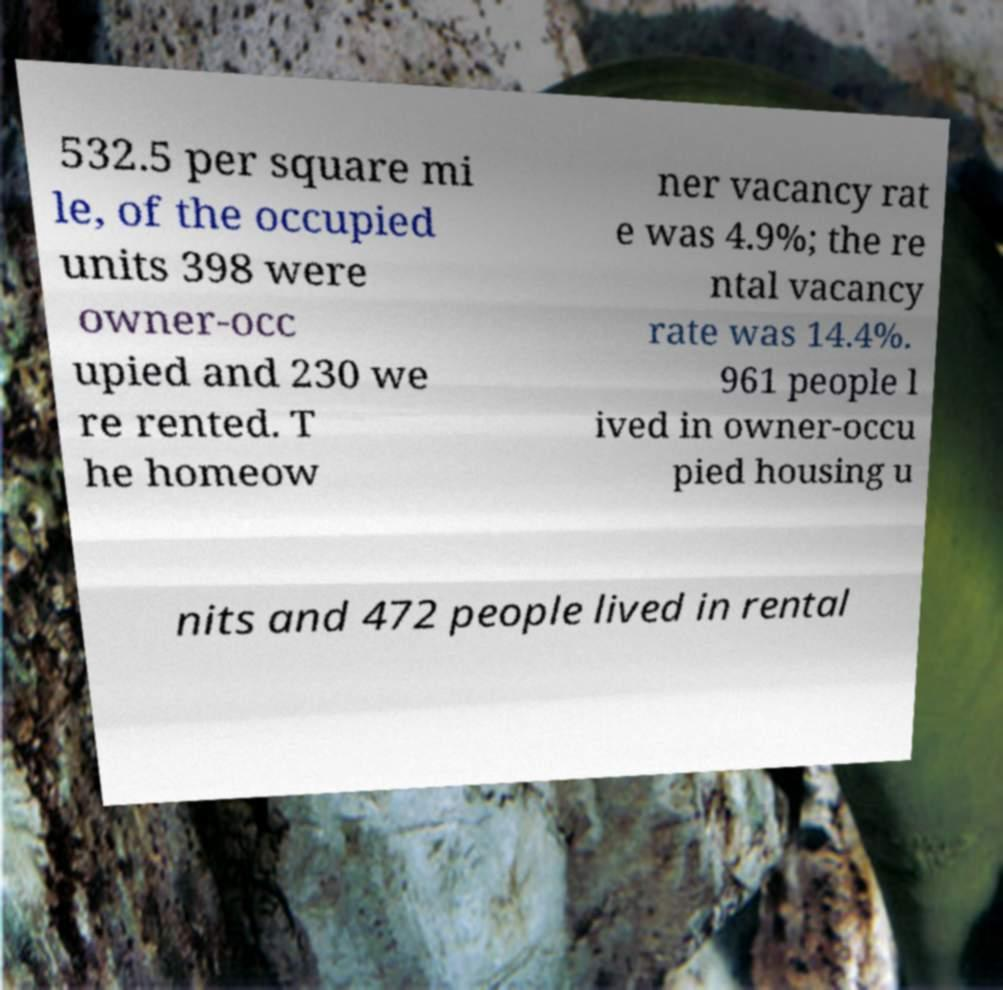Please read and relay the text visible in this image. What does it say? 532.5 per square mi le, of the occupied units 398 were owner-occ upied and 230 we re rented. T he homeow ner vacancy rat e was 4.9%; the re ntal vacancy rate was 14.4%. 961 people l ived in owner-occu pied housing u nits and 472 people lived in rental 